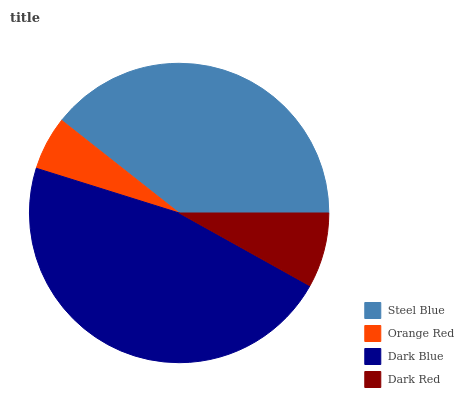Is Orange Red the minimum?
Answer yes or no. Yes. Is Dark Blue the maximum?
Answer yes or no. Yes. Is Dark Blue the minimum?
Answer yes or no. No. Is Orange Red the maximum?
Answer yes or no. No. Is Dark Blue greater than Orange Red?
Answer yes or no. Yes. Is Orange Red less than Dark Blue?
Answer yes or no. Yes. Is Orange Red greater than Dark Blue?
Answer yes or no. No. Is Dark Blue less than Orange Red?
Answer yes or no. No. Is Steel Blue the high median?
Answer yes or no. Yes. Is Dark Red the low median?
Answer yes or no. Yes. Is Orange Red the high median?
Answer yes or no. No. Is Orange Red the low median?
Answer yes or no. No. 